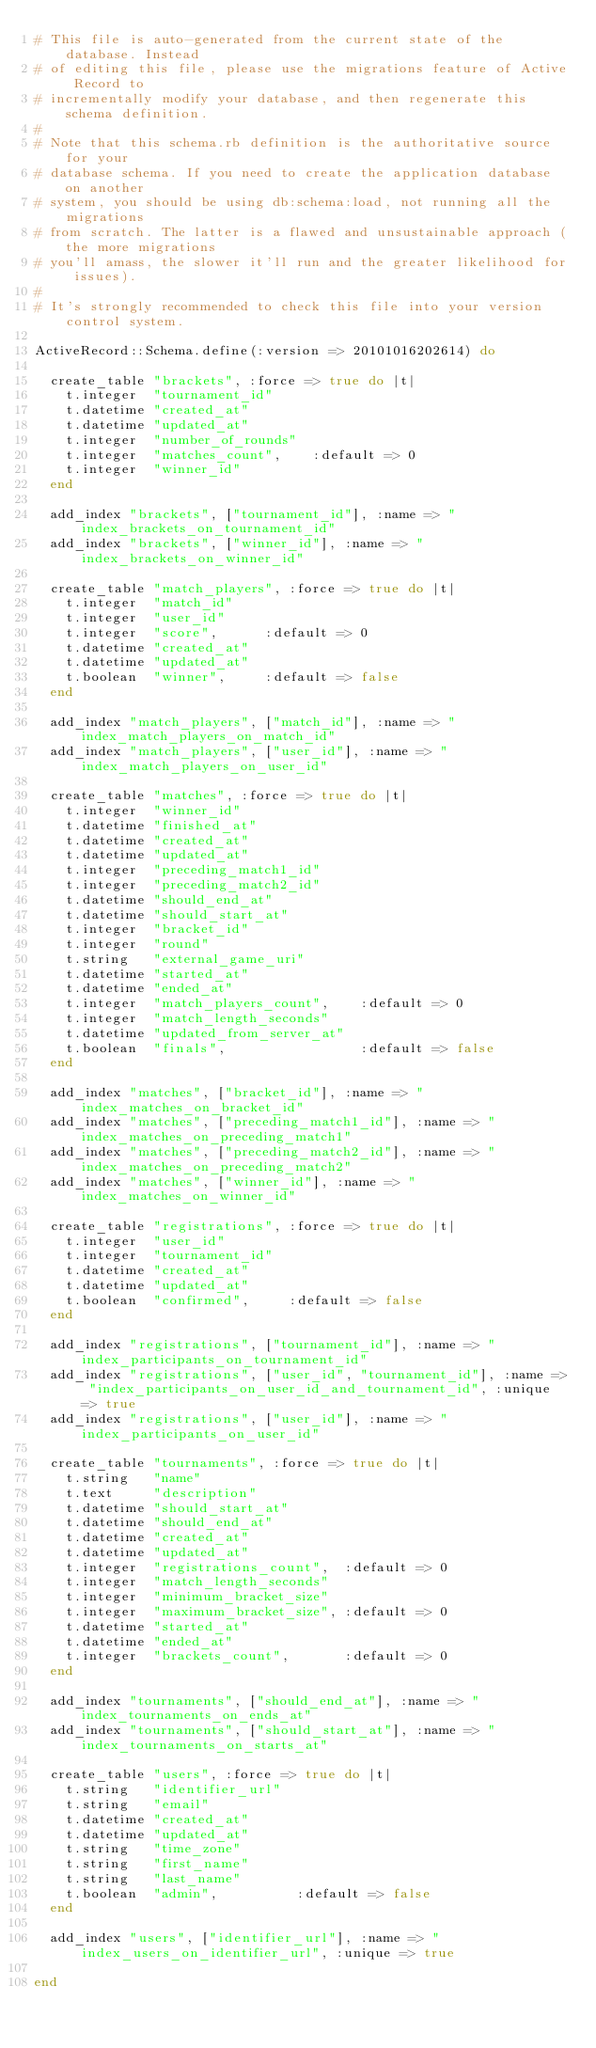<code> <loc_0><loc_0><loc_500><loc_500><_Ruby_># This file is auto-generated from the current state of the database. Instead
# of editing this file, please use the migrations feature of Active Record to
# incrementally modify your database, and then regenerate this schema definition.
#
# Note that this schema.rb definition is the authoritative source for your
# database schema. If you need to create the application database on another
# system, you should be using db:schema:load, not running all the migrations
# from scratch. The latter is a flawed and unsustainable approach (the more migrations
# you'll amass, the slower it'll run and the greater likelihood for issues).
#
# It's strongly recommended to check this file into your version control system.

ActiveRecord::Schema.define(:version => 20101016202614) do

  create_table "brackets", :force => true do |t|
    t.integer  "tournament_id"
    t.datetime "created_at"
    t.datetime "updated_at"
    t.integer  "number_of_rounds"
    t.integer  "matches_count",    :default => 0
    t.integer  "winner_id"
  end

  add_index "brackets", ["tournament_id"], :name => "index_brackets_on_tournament_id"
  add_index "brackets", ["winner_id"], :name => "index_brackets_on_winner_id"

  create_table "match_players", :force => true do |t|
    t.integer  "match_id"
    t.integer  "user_id"
    t.integer  "score",      :default => 0
    t.datetime "created_at"
    t.datetime "updated_at"
    t.boolean  "winner",     :default => false
  end

  add_index "match_players", ["match_id"], :name => "index_match_players_on_match_id"
  add_index "match_players", ["user_id"], :name => "index_match_players_on_user_id"

  create_table "matches", :force => true do |t|
    t.integer  "winner_id"
    t.datetime "finished_at"
    t.datetime "created_at"
    t.datetime "updated_at"
    t.integer  "preceding_match1_id"
    t.integer  "preceding_match2_id"
    t.datetime "should_end_at"
    t.datetime "should_start_at"
    t.integer  "bracket_id"
    t.integer  "round"
    t.string   "external_game_uri"
    t.datetime "started_at"
    t.datetime "ended_at"
    t.integer  "match_players_count",    :default => 0
    t.integer  "match_length_seconds"
    t.datetime "updated_from_server_at"
    t.boolean  "finals",                 :default => false
  end

  add_index "matches", ["bracket_id"], :name => "index_matches_on_bracket_id"
  add_index "matches", ["preceding_match1_id"], :name => "index_matches_on_preceding_match1"
  add_index "matches", ["preceding_match2_id"], :name => "index_matches_on_preceding_match2"
  add_index "matches", ["winner_id"], :name => "index_matches_on_winner_id"

  create_table "registrations", :force => true do |t|
    t.integer  "user_id"
    t.integer  "tournament_id"
    t.datetime "created_at"
    t.datetime "updated_at"
    t.boolean  "confirmed",     :default => false
  end

  add_index "registrations", ["tournament_id"], :name => "index_participants_on_tournament_id"
  add_index "registrations", ["user_id", "tournament_id"], :name => "index_participants_on_user_id_and_tournament_id", :unique => true
  add_index "registrations", ["user_id"], :name => "index_participants_on_user_id"

  create_table "tournaments", :force => true do |t|
    t.string   "name"
    t.text     "description"
    t.datetime "should_start_at"
    t.datetime "should_end_at"
    t.datetime "created_at"
    t.datetime "updated_at"
    t.integer  "registrations_count",  :default => 0
    t.integer  "match_length_seconds"
    t.integer  "minimum_bracket_size"
    t.integer  "maximum_bracket_size", :default => 0
    t.datetime "started_at"
    t.datetime "ended_at"
    t.integer  "brackets_count",       :default => 0
  end

  add_index "tournaments", ["should_end_at"], :name => "index_tournaments_on_ends_at"
  add_index "tournaments", ["should_start_at"], :name => "index_tournaments_on_starts_at"

  create_table "users", :force => true do |t|
    t.string   "identifier_url"
    t.string   "email"
    t.datetime "created_at"
    t.datetime "updated_at"
    t.string   "time_zone"
    t.string   "first_name"
    t.string   "last_name"
    t.boolean  "admin",          :default => false
  end

  add_index "users", ["identifier_url"], :name => "index_users_on_identifier_url", :unique => true

end
</code> 